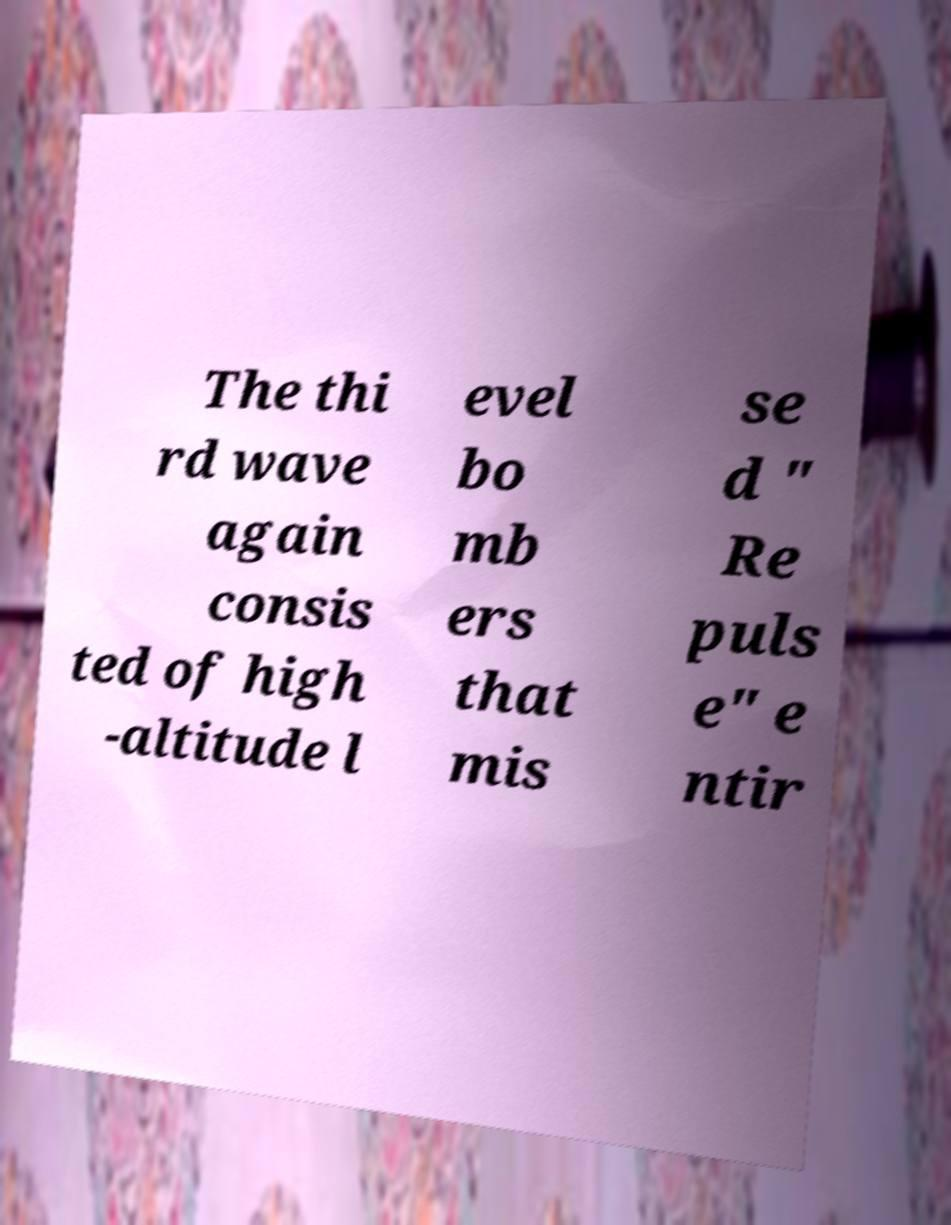Can you accurately transcribe the text from the provided image for me? The thi rd wave again consis ted of high -altitude l evel bo mb ers that mis se d " Re puls e" e ntir 